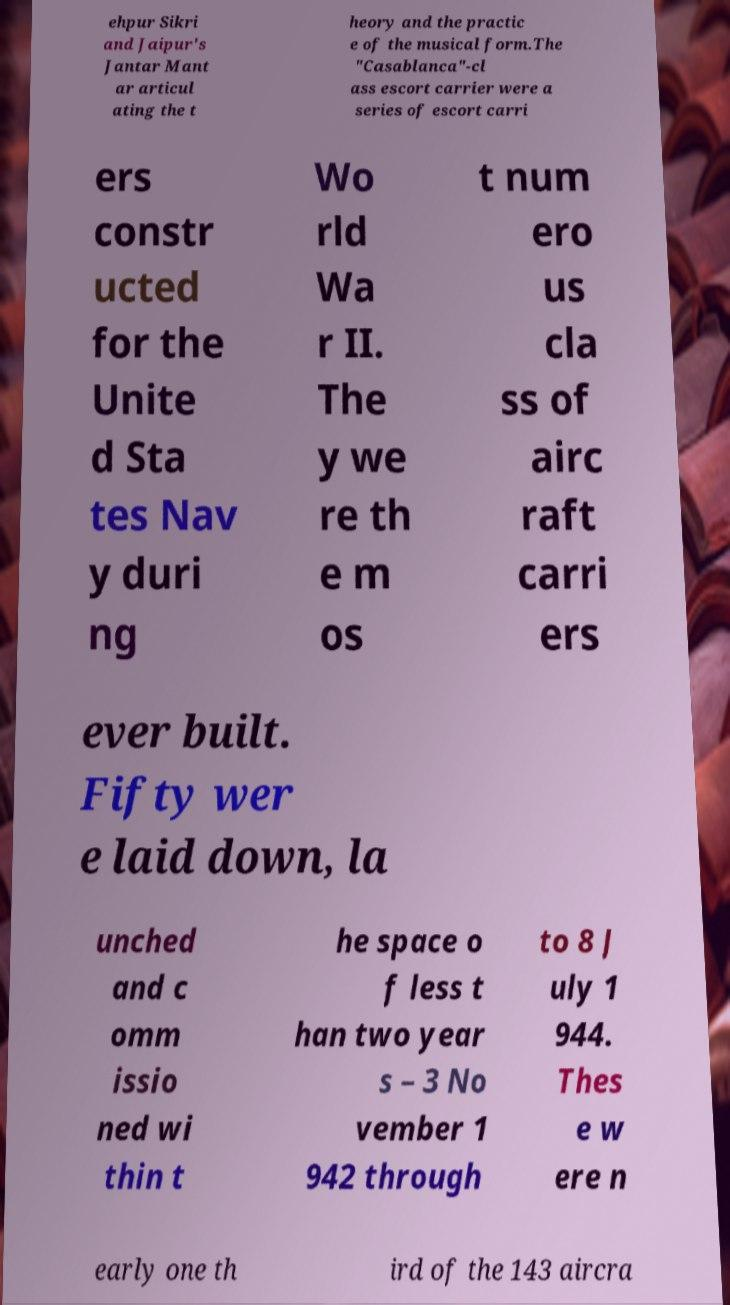Please identify and transcribe the text found in this image. ehpur Sikri and Jaipur's Jantar Mant ar articul ating the t heory and the practic e of the musical form.The "Casablanca"-cl ass escort carrier were a series of escort carri ers constr ucted for the Unite d Sta tes Nav y duri ng Wo rld Wa r II. The y we re th e m os t num ero us cla ss of airc raft carri ers ever built. Fifty wer e laid down, la unched and c omm issio ned wi thin t he space o f less t han two year s – 3 No vember 1 942 through to 8 J uly 1 944. Thes e w ere n early one th ird of the 143 aircra 